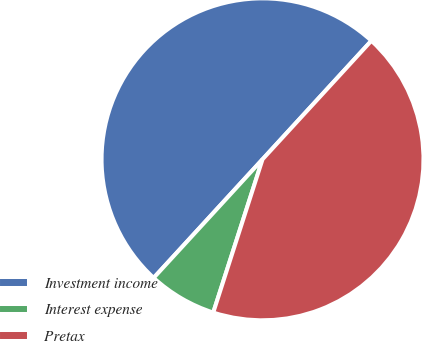Convert chart to OTSL. <chart><loc_0><loc_0><loc_500><loc_500><pie_chart><fcel>Investment income<fcel>Interest expense<fcel>Pretax<nl><fcel>50.0%<fcel>6.87%<fcel>43.13%<nl></chart> 